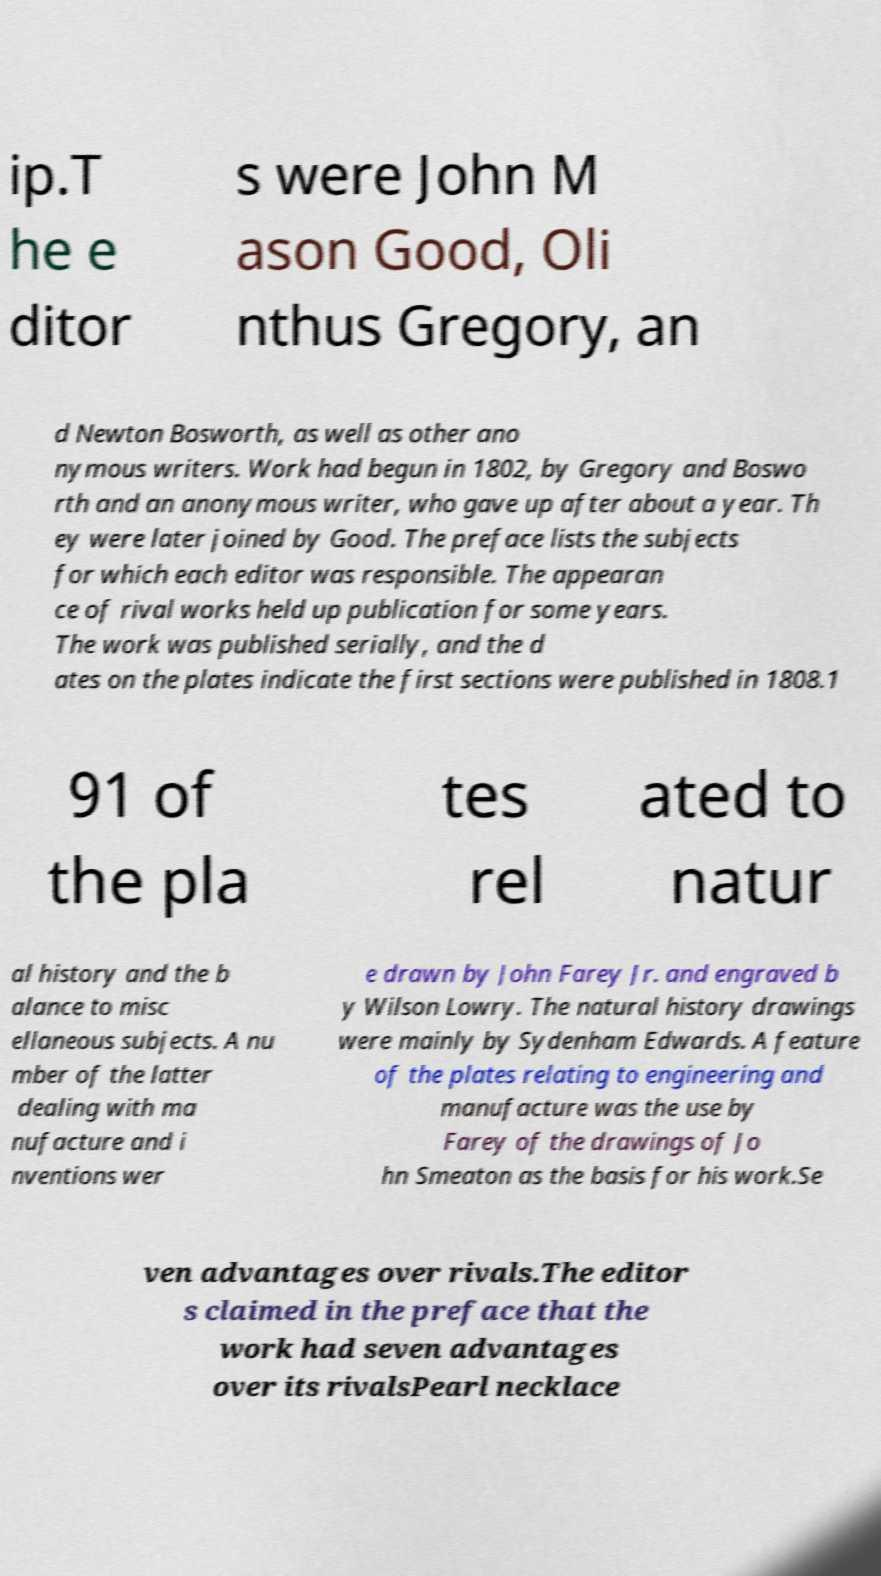Please identify and transcribe the text found in this image. ip.T he e ditor s were John M ason Good, Oli nthus Gregory, an d Newton Bosworth, as well as other ano nymous writers. Work had begun in 1802, by Gregory and Boswo rth and an anonymous writer, who gave up after about a year. Th ey were later joined by Good. The preface lists the subjects for which each editor was responsible. The appearan ce of rival works held up publication for some years. The work was published serially, and the d ates on the plates indicate the first sections were published in 1808.1 91 of the pla tes rel ated to natur al history and the b alance to misc ellaneous subjects. A nu mber of the latter dealing with ma nufacture and i nventions wer e drawn by John Farey Jr. and engraved b y Wilson Lowry. The natural history drawings were mainly by Sydenham Edwards. A feature of the plates relating to engineering and manufacture was the use by Farey of the drawings of Jo hn Smeaton as the basis for his work.Se ven advantages over rivals.The editor s claimed in the preface that the work had seven advantages over its rivalsPearl necklace 